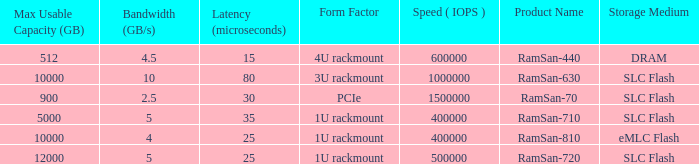Can you give me this table as a dict? {'header': ['Max Usable Capacity (GB)', 'Bandwidth (GB/s)', 'Latency (microseconds)', 'Form Factor', 'Speed ( IOPS )', 'Product Name', 'Storage Medium'], 'rows': [['512', '4.5', '15', '4U rackmount', '600000', 'RamSan-440', 'DRAM'], ['10000', '10', '80', '3U rackmount', '1000000', 'RamSan-630', 'SLC Flash'], ['900', '2.5', '30', 'PCIe', '1500000', 'RamSan-70', 'SLC Flash'], ['5000', '5', '35', '1U rackmount', '400000', 'RamSan-710', 'SLC Flash'], ['10000', '4', '25', '1U rackmount', '400000', 'RamSan-810', 'eMLC Flash'], ['12000', '5', '25', '1U rackmount', '500000', 'RamSan-720', 'SLC Flash']]} What is the Input/output operations per second for the emlc flash? 400000.0. 